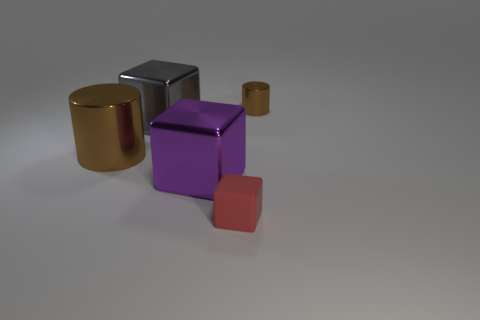Subtract 1 cubes. How many cubes are left? 2 Add 2 metal cubes. How many objects exist? 7 Subtract all blocks. How many objects are left? 2 Add 1 red things. How many red things are left? 2 Add 2 small metal things. How many small metal things exist? 3 Subtract 0 yellow cylinders. How many objects are left? 5 Subtract all tiny cyan cubes. Subtract all purple metal blocks. How many objects are left? 4 